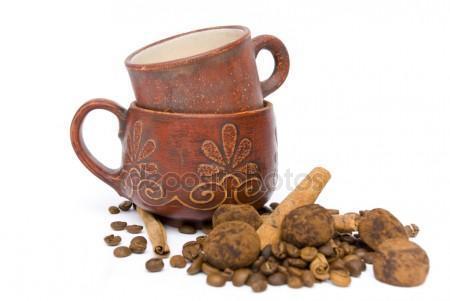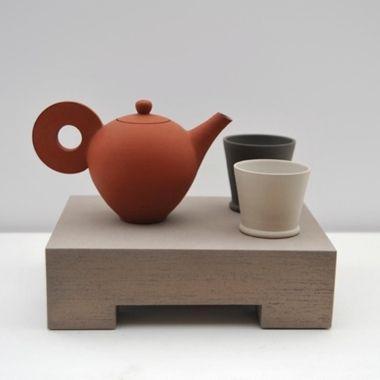The first image is the image on the left, the second image is the image on the right. Given the left and right images, does the statement "There is a teapot with cups" hold true? Answer yes or no. Yes. The first image is the image on the left, the second image is the image on the right. For the images shown, is this caption "An image of a pair of filled mugs includes a small pile of loose coffee beans." true? Answer yes or no. No. 